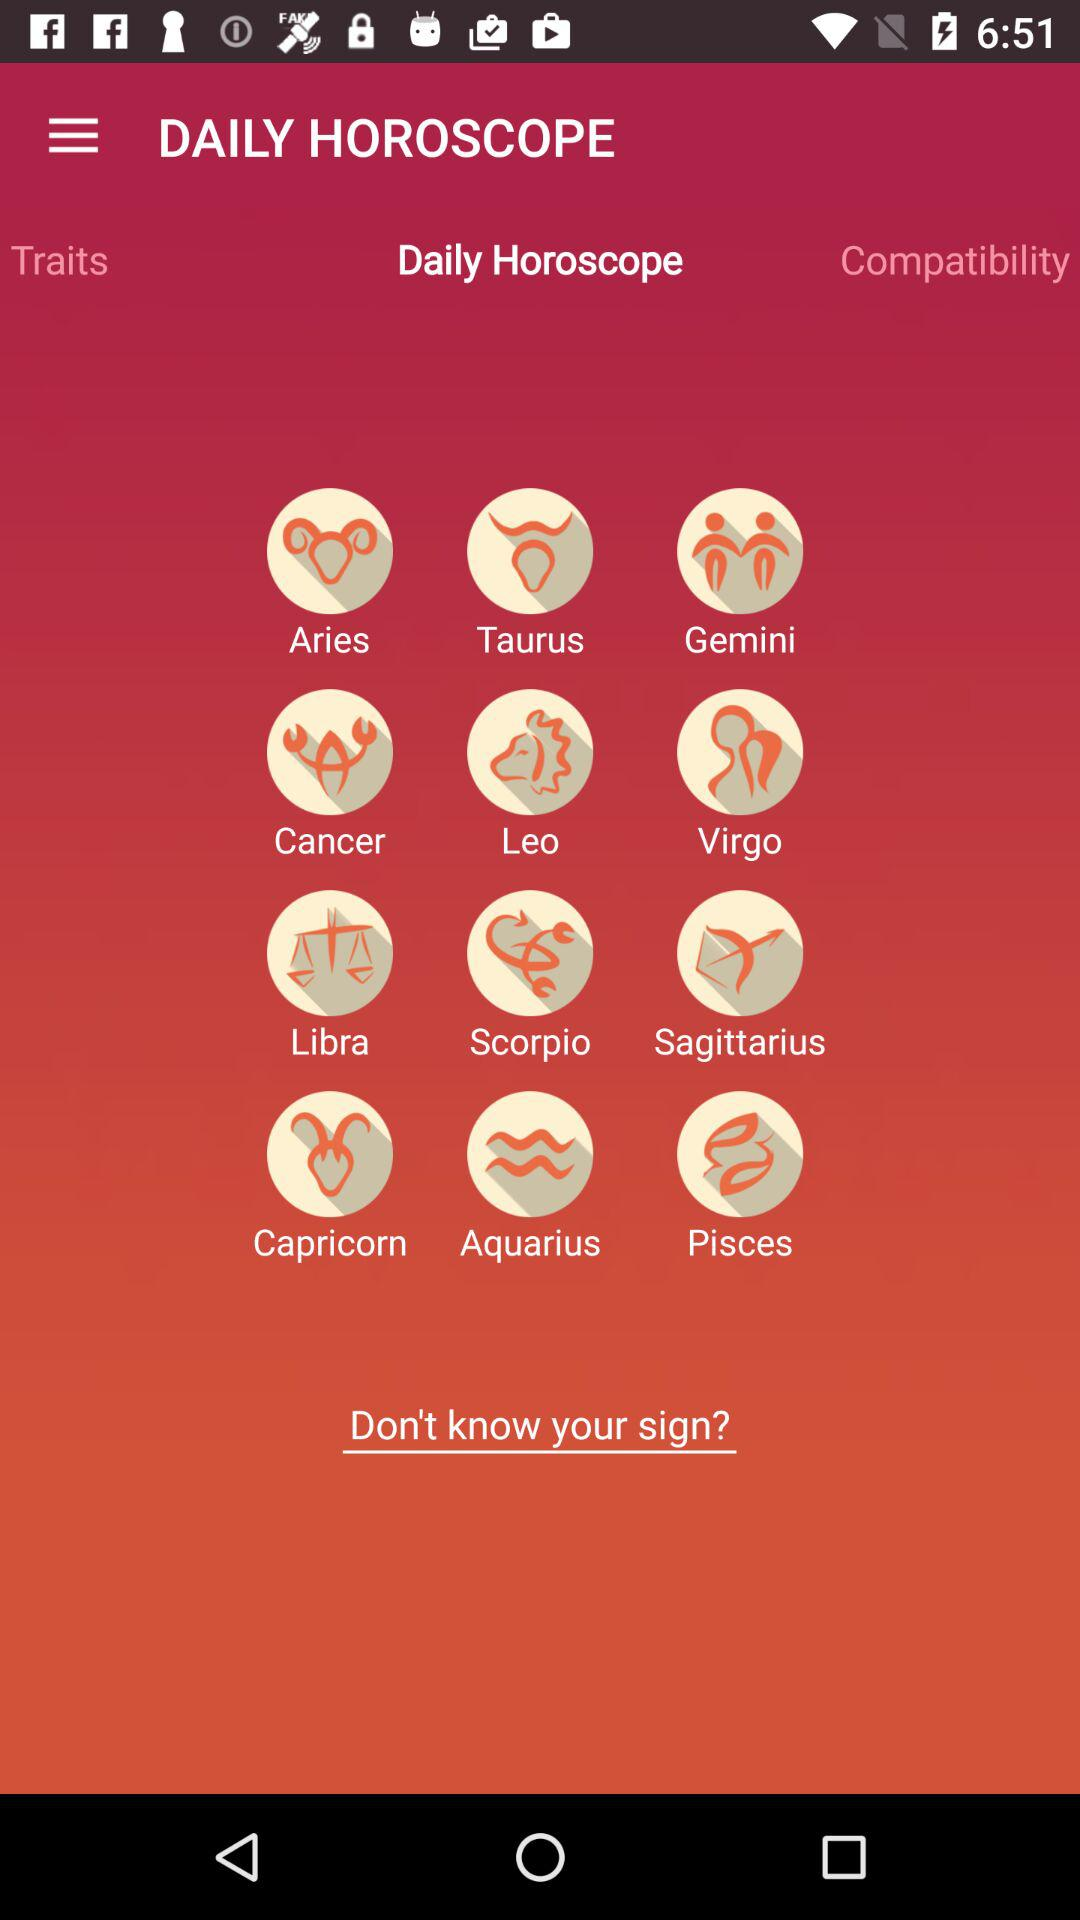What are the different zodiac signs available? The available zodiac signs are "Aries", "Taurus", "Gemini", "Cancer", "Leo", "Virgo", "Libra", "Scorpio", "Sagittarius", "Capricorn", "Aquarius", and "Pisces". 